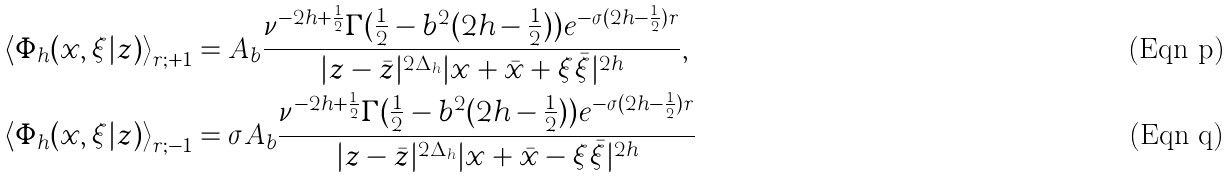Convert formula to latex. <formula><loc_0><loc_0><loc_500><loc_500>& \left \langle \Phi _ { h } ( x , \xi | z ) \right \rangle _ { r ; + 1 } = A _ { b } \frac { \nu ^ { - 2 h + \frac { 1 } { 2 } } \Gamma ( \frac { 1 } { 2 } - b ^ { 2 } ( 2 h - \frac { 1 } { 2 } ) ) e ^ { - \sigma ( 2 h - \frac { 1 } { 2 } ) r } } { | z - \bar { z } | ^ { 2 \Delta _ { h } } | x + \bar { x } + \xi \bar { \xi } | ^ { 2 h } } , \\ & \left \langle \Phi _ { h } ( x , \xi | z ) \right \rangle _ { r ; - 1 } = \sigma A _ { b } \frac { \nu ^ { - 2 h + \frac { 1 } { 2 } } \Gamma ( \frac { 1 } { 2 } - b ^ { 2 } ( 2 h - \frac { 1 } { 2 } ) ) e ^ { - \sigma ( 2 h - \frac { 1 } { 2 } ) r } } { | z - \bar { z } | ^ { 2 \Delta _ { h } } | x + \bar { x } - \xi \bar { \xi } | ^ { 2 h } }</formula> 